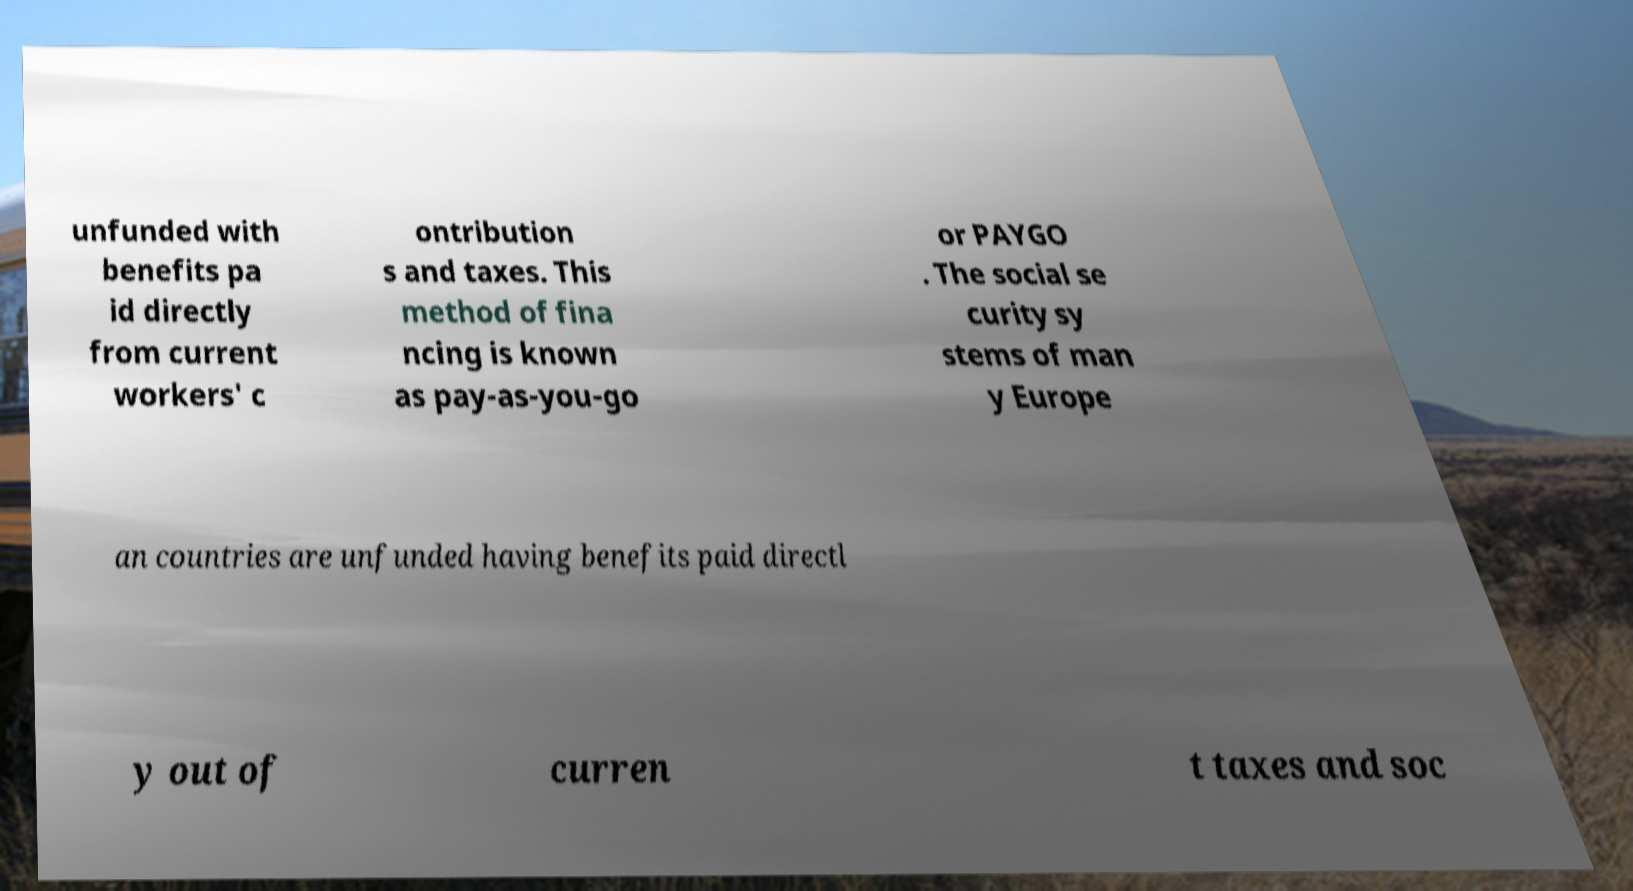Please identify and transcribe the text found in this image. unfunded with benefits pa id directly from current workers' c ontribution s and taxes. This method of fina ncing is known as pay-as-you-go or PAYGO . The social se curity sy stems of man y Europe an countries are unfunded having benefits paid directl y out of curren t taxes and soc 